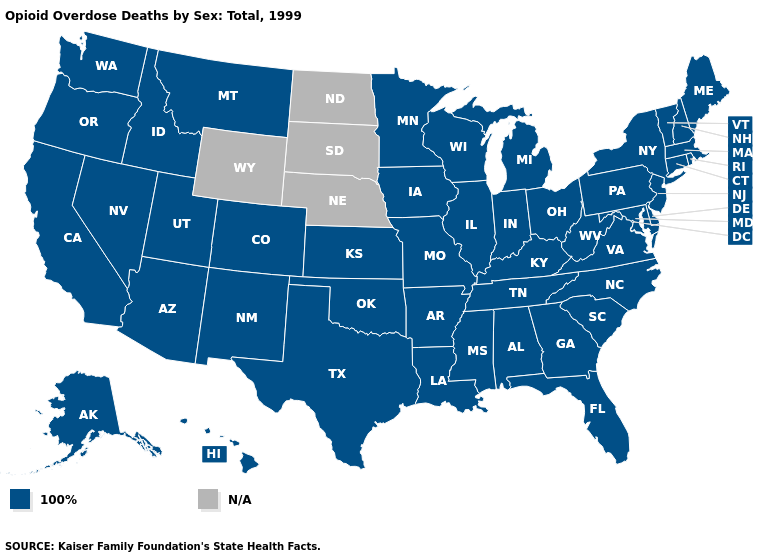What is the value of Texas?
Short answer required. 100%. Which states have the lowest value in the MidWest?
Answer briefly. Illinois, Indiana, Iowa, Kansas, Michigan, Minnesota, Missouri, Ohio, Wisconsin. Name the states that have a value in the range 100%?
Keep it brief. Alabama, Alaska, Arizona, Arkansas, California, Colorado, Connecticut, Delaware, Florida, Georgia, Hawaii, Idaho, Illinois, Indiana, Iowa, Kansas, Kentucky, Louisiana, Maine, Maryland, Massachusetts, Michigan, Minnesota, Mississippi, Missouri, Montana, Nevada, New Hampshire, New Jersey, New Mexico, New York, North Carolina, Ohio, Oklahoma, Oregon, Pennsylvania, Rhode Island, South Carolina, Tennessee, Texas, Utah, Vermont, Virginia, Washington, West Virginia, Wisconsin. Name the states that have a value in the range 100%?
Keep it brief. Alabama, Alaska, Arizona, Arkansas, California, Colorado, Connecticut, Delaware, Florida, Georgia, Hawaii, Idaho, Illinois, Indiana, Iowa, Kansas, Kentucky, Louisiana, Maine, Maryland, Massachusetts, Michigan, Minnesota, Mississippi, Missouri, Montana, Nevada, New Hampshire, New Jersey, New Mexico, New York, North Carolina, Ohio, Oklahoma, Oregon, Pennsylvania, Rhode Island, South Carolina, Tennessee, Texas, Utah, Vermont, Virginia, Washington, West Virginia, Wisconsin. Name the states that have a value in the range N/A?
Concise answer only. Nebraska, North Dakota, South Dakota, Wyoming. What is the highest value in the USA?
Be succinct. 100%. Which states have the lowest value in the Northeast?
Write a very short answer. Connecticut, Maine, Massachusetts, New Hampshire, New Jersey, New York, Pennsylvania, Rhode Island, Vermont. Name the states that have a value in the range N/A?
Give a very brief answer. Nebraska, North Dakota, South Dakota, Wyoming. Name the states that have a value in the range 100%?
Keep it brief. Alabama, Alaska, Arizona, Arkansas, California, Colorado, Connecticut, Delaware, Florida, Georgia, Hawaii, Idaho, Illinois, Indiana, Iowa, Kansas, Kentucky, Louisiana, Maine, Maryland, Massachusetts, Michigan, Minnesota, Mississippi, Missouri, Montana, Nevada, New Hampshire, New Jersey, New Mexico, New York, North Carolina, Ohio, Oklahoma, Oregon, Pennsylvania, Rhode Island, South Carolina, Tennessee, Texas, Utah, Vermont, Virginia, Washington, West Virginia, Wisconsin. What is the value of Montana?
Give a very brief answer. 100%. What is the value of Colorado?
Quick response, please. 100%. What is the highest value in the South ?
Keep it brief. 100%. Name the states that have a value in the range N/A?
Answer briefly. Nebraska, North Dakota, South Dakota, Wyoming. What is the value of Maine?
Give a very brief answer. 100%. 